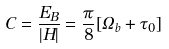Convert formula to latex. <formula><loc_0><loc_0><loc_500><loc_500>C = \frac { E _ { B } } { | H | } = \frac { \pi } { 8 } [ { { \Omega } _ { b } } + { \tau } _ { 0 } ]</formula> 